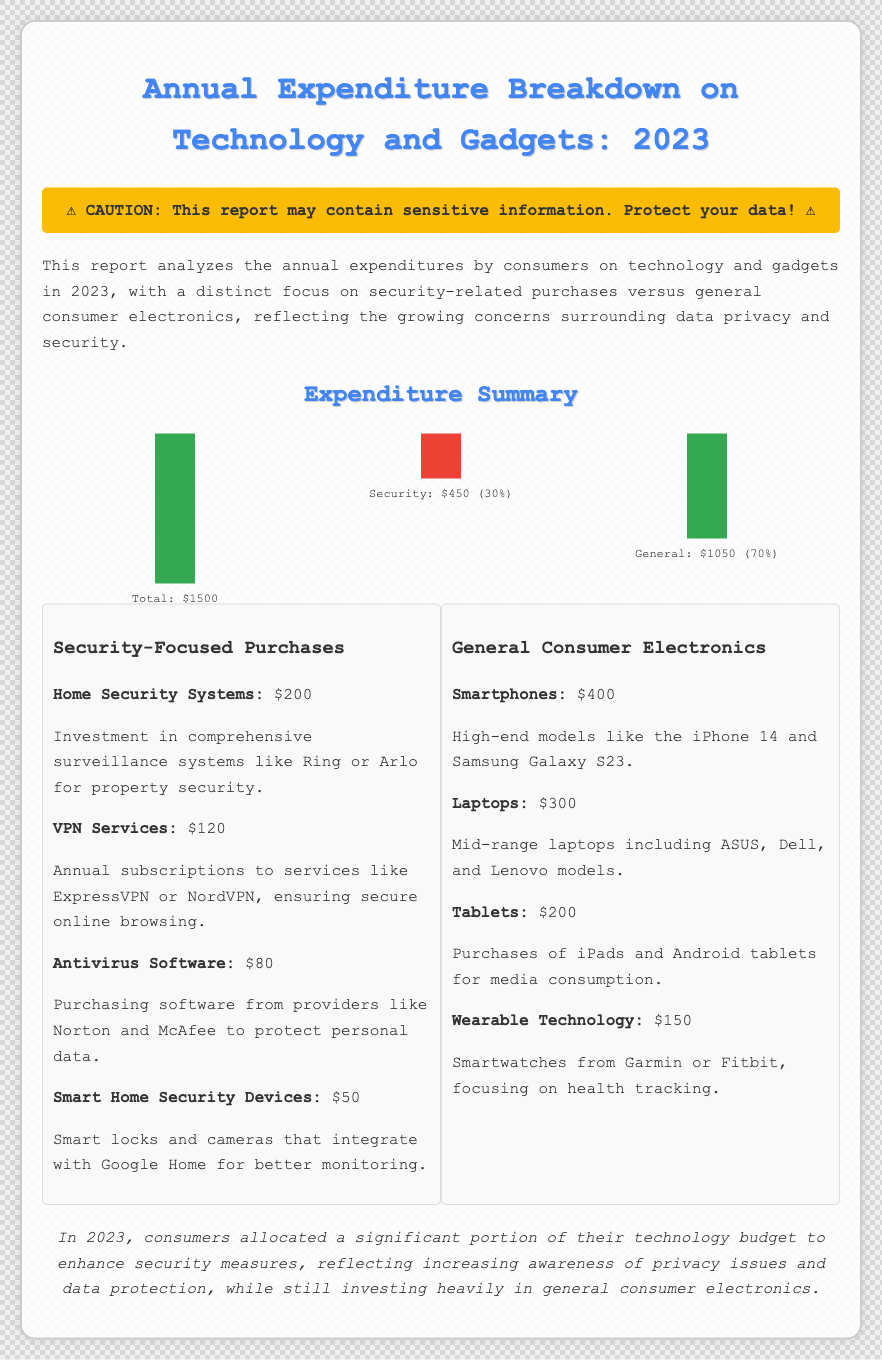What is the total expenditure on technology and gadgets? The total expenditure is explicitly stated in the chart showing the expenditures.
Answer: $1500 How much was spent on security-focused purchases? The expenditure detail highlights that the amount allocated for security-focused purchases is directly labeled.
Answer: $450 What percentage of the total expenditure is allocated for general consumer electronics? The calculation of the percentage for general consumer electronics is detailed in the expenditure summary.
Answer: 70% What was the investment in home security systems? The document lists the specific amount allocated for home security systems under security-focused purchases.
Answer: $200 Which smartphone models were mentioned as examples? The expenditure details cite specific smartphone models within the general consumer electronics section.
Answer: iPhone 14 and Samsung Galaxy S23 What is the total expenditure on antivirus software? The expenditure detail explicitly states the amount spent on antivirus software in the security category.
Answer: $80 How much was allocated for VPN services? The specific expenditure on VPN services is listed among the security-focused purchases.
Answer: $120 What is the investment category with the highest expenditure? The document summarizes expenditures indicating the category with the greatest financial allocation among the options.
Answer: General consumer electronics 